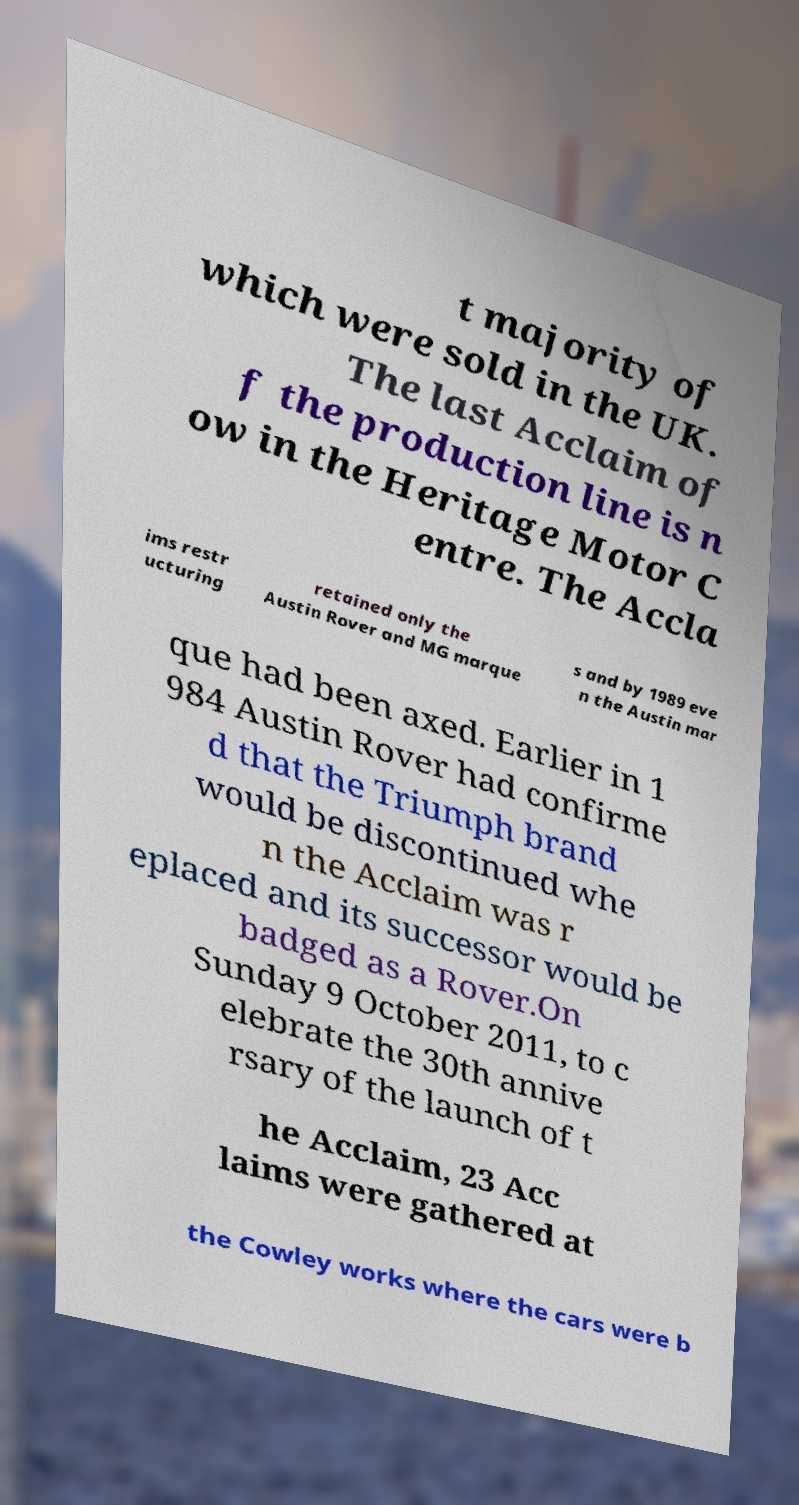Could you assist in decoding the text presented in this image and type it out clearly? t majority of which were sold in the UK. The last Acclaim of f the production line is n ow in the Heritage Motor C entre. The Accla ims restr ucturing retained only the Austin Rover and MG marque s and by 1989 eve n the Austin mar que had been axed. Earlier in 1 984 Austin Rover had confirme d that the Triumph brand would be discontinued whe n the Acclaim was r eplaced and its successor would be badged as a Rover.On Sunday 9 October 2011, to c elebrate the 30th annive rsary of the launch of t he Acclaim, 23 Acc laims were gathered at the Cowley works where the cars were b 